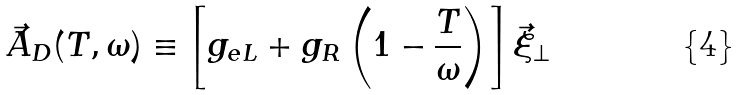Convert formula to latex. <formula><loc_0><loc_0><loc_500><loc_500>\vec { A } _ { D } ( T , \omega ) \equiv \left [ g _ { e L } + g _ { R } \left ( 1 - \frac { T } { \omega } \right ) \right ] \vec { \xi } _ { \perp }</formula> 